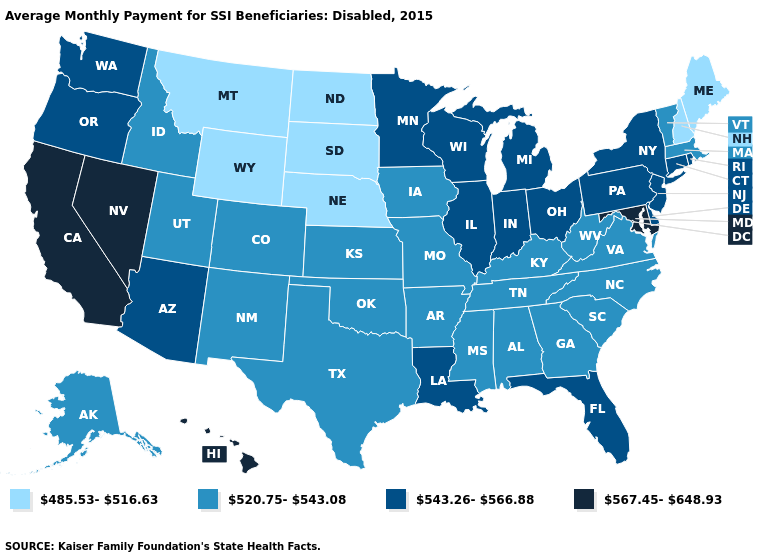Which states have the highest value in the USA?
Concise answer only. California, Hawaii, Maryland, Nevada. Does the first symbol in the legend represent the smallest category?
Concise answer only. Yes. Name the states that have a value in the range 543.26-566.88?
Quick response, please. Arizona, Connecticut, Delaware, Florida, Illinois, Indiana, Louisiana, Michigan, Minnesota, New Jersey, New York, Ohio, Oregon, Pennsylvania, Rhode Island, Washington, Wisconsin. Name the states that have a value in the range 543.26-566.88?
Quick response, please. Arizona, Connecticut, Delaware, Florida, Illinois, Indiana, Louisiana, Michigan, Minnesota, New Jersey, New York, Ohio, Oregon, Pennsylvania, Rhode Island, Washington, Wisconsin. Among the states that border Arizona , does Utah have the highest value?
Quick response, please. No. What is the value of Iowa?
Concise answer only. 520.75-543.08. Which states have the highest value in the USA?
Quick response, please. California, Hawaii, Maryland, Nevada. Name the states that have a value in the range 485.53-516.63?
Keep it brief. Maine, Montana, Nebraska, New Hampshire, North Dakota, South Dakota, Wyoming. Does Nevada have a higher value than Tennessee?
Answer briefly. Yes. Does Vermont have the highest value in the Northeast?
Give a very brief answer. No. Does Massachusetts have the highest value in the Northeast?
Give a very brief answer. No. Does the map have missing data?
Keep it brief. No. What is the highest value in the USA?
Write a very short answer. 567.45-648.93. What is the value of Maine?
Give a very brief answer. 485.53-516.63. Does California have the highest value in the USA?
Concise answer only. Yes. 